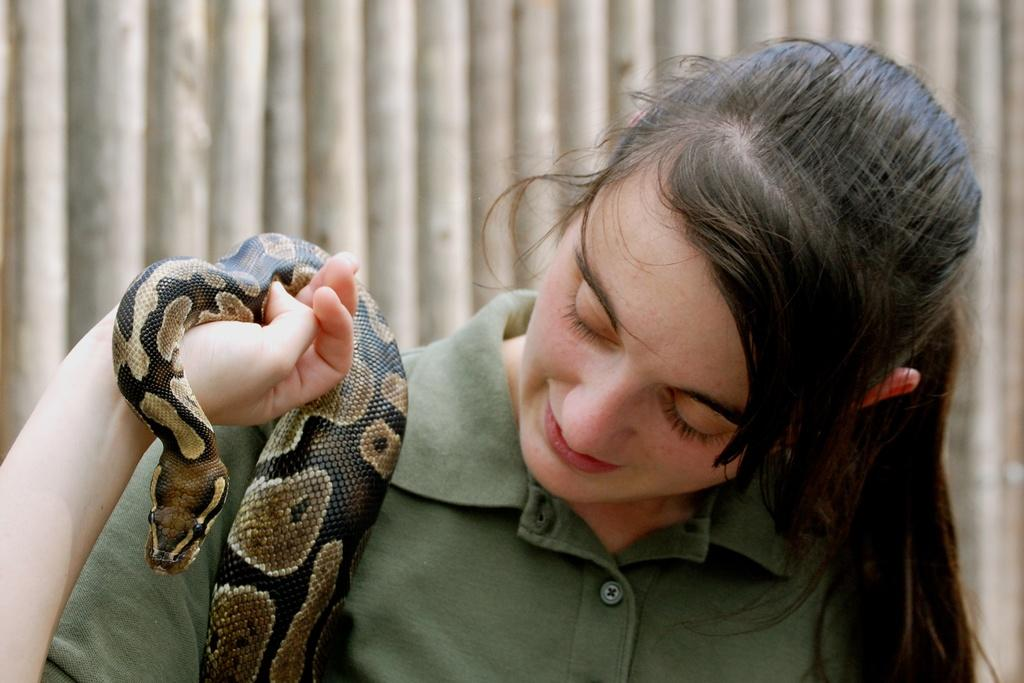Who or what is the main subject in the image? There is a person in the image. What is the person wearing? The person is wearing a green dress. What is the person holding in the image? The person is holding a snake. Can you describe the snake's appearance? The snake has black and brown colors. What is the color of the background in the image? The background of the image is ash-colored. What type of knot is the person tying on the snake's tail in the image? There is no knot being tied on the snake's tail in the image; the person is simply holding the snake. Can you describe the berries that the person is picking from the tree in the image? There are no berries or trees present in the image; it only features a person holding a snake against an ash-colored background. 